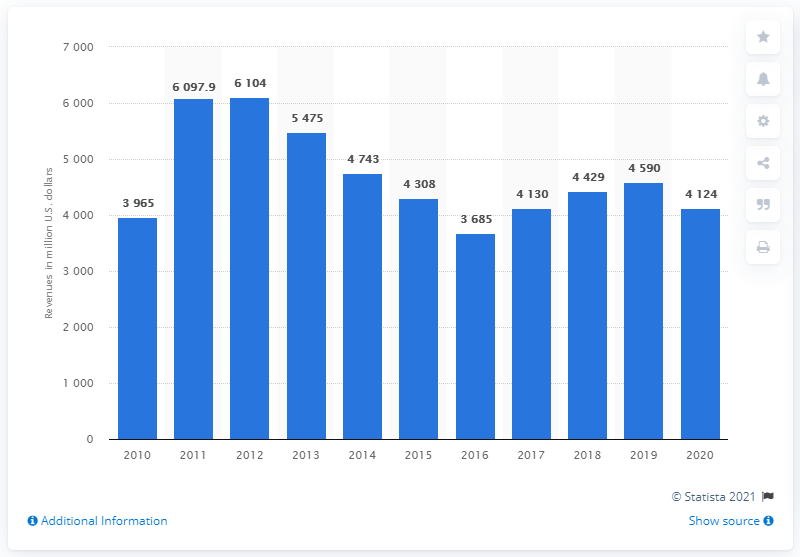Specify some key components in this picture. In 2019, CF Industries' revenue was approximately 4,124. 